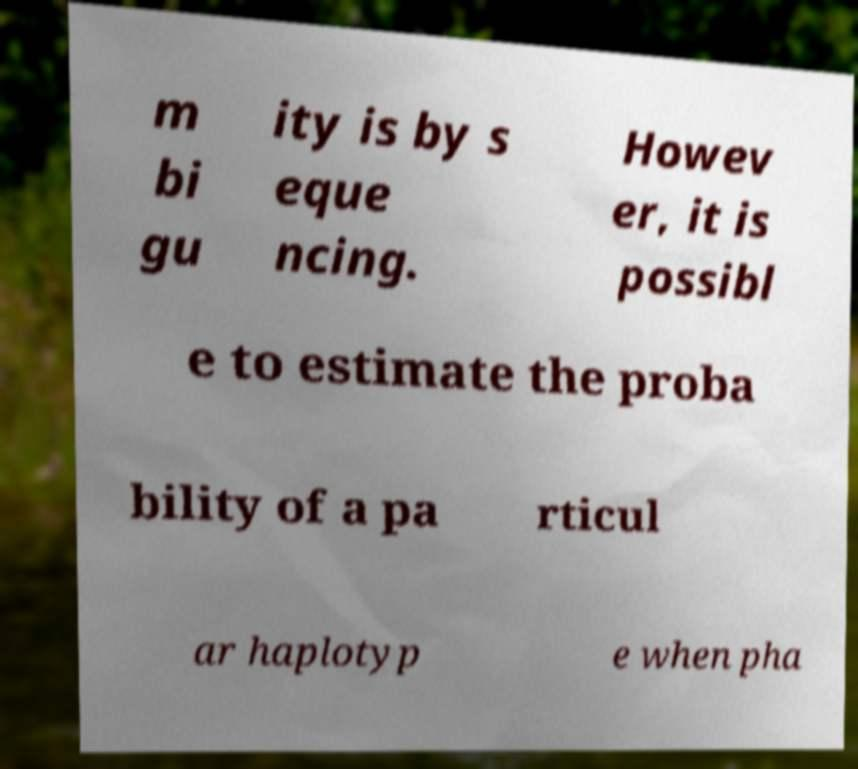I need the written content from this picture converted into text. Can you do that? m bi gu ity is by s eque ncing. Howev er, it is possibl e to estimate the proba bility of a pa rticul ar haplotyp e when pha 